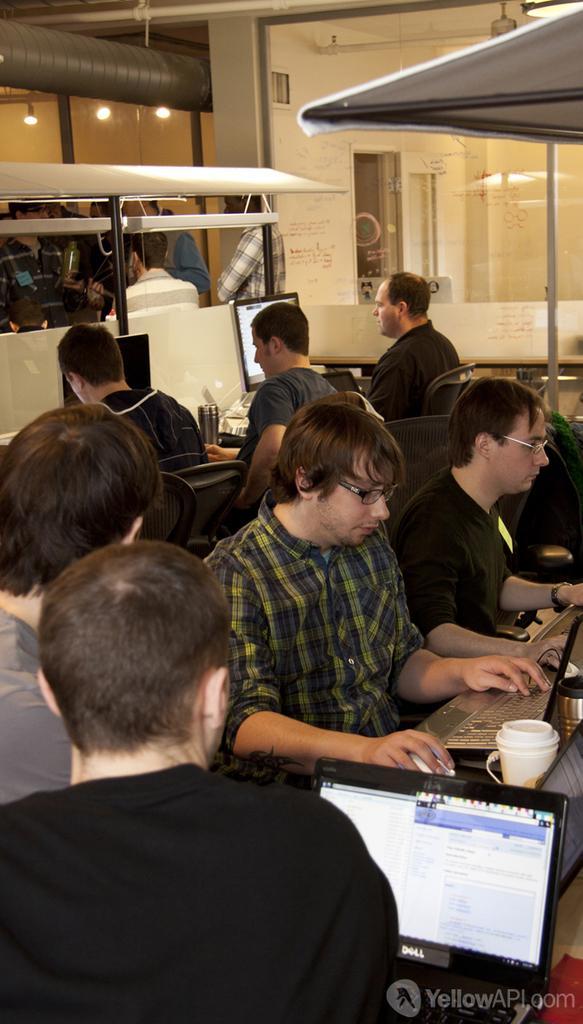Describe this image in one or two sentences. In this image, we can see a group of people. Few are sitting and standing. Here we can see monitors, cup, keyboard, bottles, glass door, wall, lights, pipe and rods. Here a person is holding a mouse. 